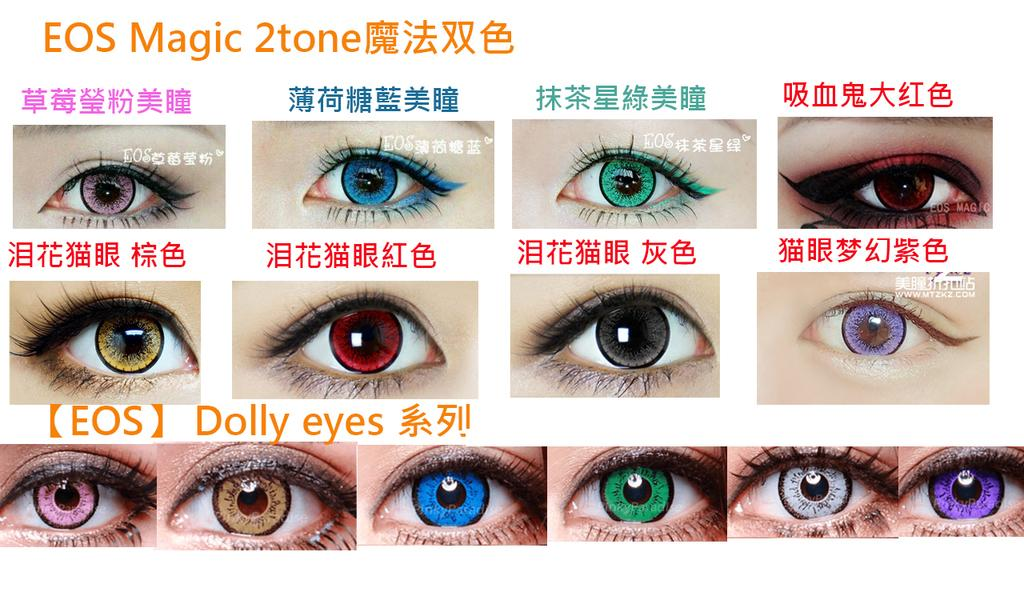What can be seen in the image related to human eyes? The image contains human eyes with different colored lenses. What else is present in the image besides the eyes? There is text present in the image. What type of winter clothing is being worn by the person in the image? There is no person or winter clothing present in the image; it only contains human eyes with different colored lenses and text. 